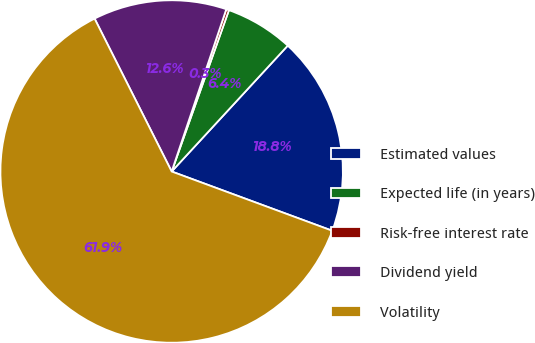Convert chart. <chart><loc_0><loc_0><loc_500><loc_500><pie_chart><fcel>Estimated values<fcel>Expected life (in years)<fcel>Risk-free interest rate<fcel>Dividend yield<fcel>Volatility<nl><fcel>18.77%<fcel>6.43%<fcel>0.26%<fcel>12.6%<fcel>61.95%<nl></chart> 